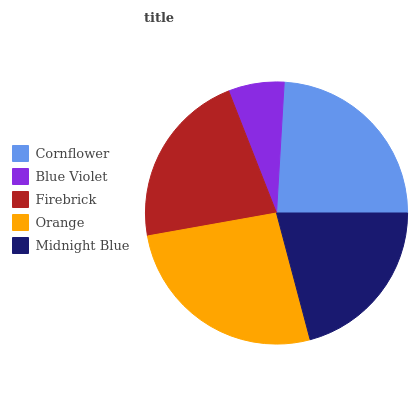Is Blue Violet the minimum?
Answer yes or no. Yes. Is Orange the maximum?
Answer yes or no. Yes. Is Firebrick the minimum?
Answer yes or no. No. Is Firebrick the maximum?
Answer yes or no. No. Is Firebrick greater than Blue Violet?
Answer yes or no. Yes. Is Blue Violet less than Firebrick?
Answer yes or no. Yes. Is Blue Violet greater than Firebrick?
Answer yes or no. No. Is Firebrick less than Blue Violet?
Answer yes or no. No. Is Firebrick the high median?
Answer yes or no. Yes. Is Firebrick the low median?
Answer yes or no. Yes. Is Orange the high median?
Answer yes or no. No. Is Blue Violet the low median?
Answer yes or no. No. 